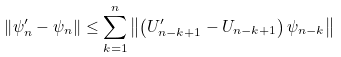Convert formula to latex. <formula><loc_0><loc_0><loc_500><loc_500>\left \| \psi _ { n } ^ { \prime } - \psi _ { n } \right \| \leq \sum _ { k = 1 } ^ { n } \left \| \left ( U _ { n - k + 1 } ^ { \prime } - U _ { n - k + 1 } \right ) \psi _ { n - k } \right \|</formula> 